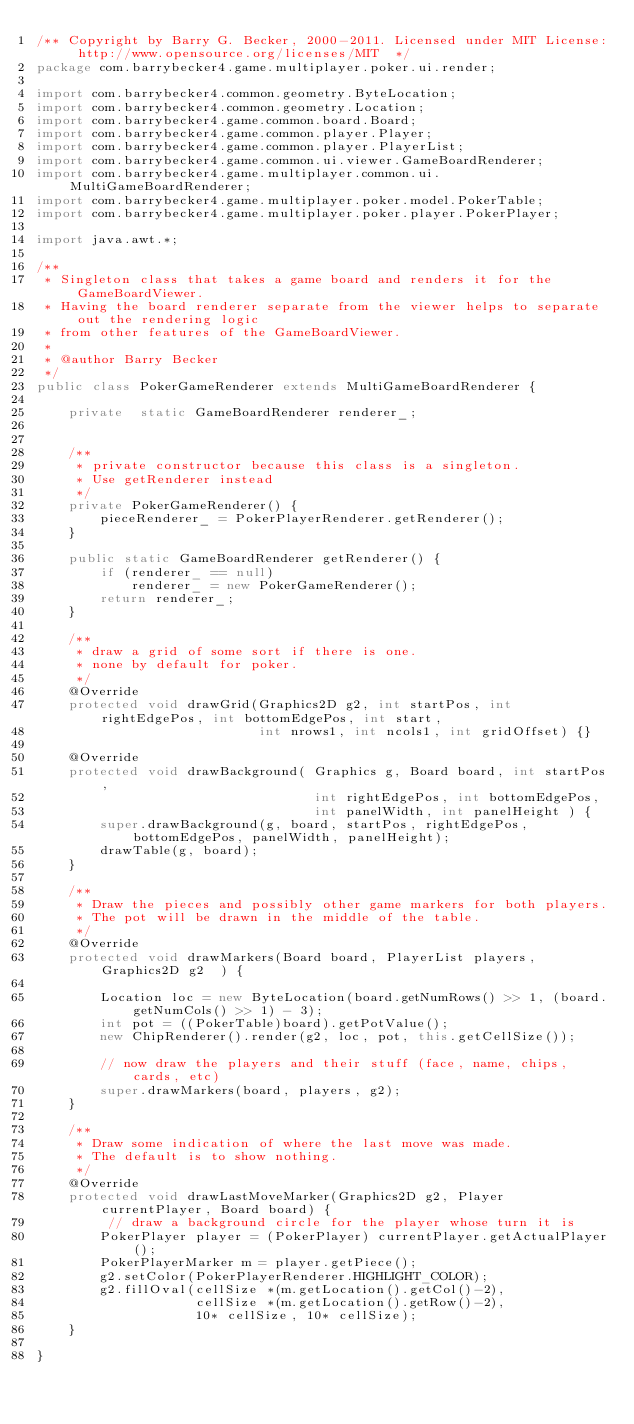Convert code to text. <code><loc_0><loc_0><loc_500><loc_500><_Java_>/** Copyright by Barry G. Becker, 2000-2011. Licensed under MIT License: http://www.opensource.org/licenses/MIT  */
package com.barrybecker4.game.multiplayer.poker.ui.render;

import com.barrybecker4.common.geometry.ByteLocation;
import com.barrybecker4.common.geometry.Location;
import com.barrybecker4.game.common.board.Board;
import com.barrybecker4.game.common.player.Player;
import com.barrybecker4.game.common.player.PlayerList;
import com.barrybecker4.game.common.ui.viewer.GameBoardRenderer;
import com.barrybecker4.game.multiplayer.common.ui.MultiGameBoardRenderer;
import com.barrybecker4.game.multiplayer.poker.model.PokerTable;
import com.barrybecker4.game.multiplayer.poker.player.PokerPlayer;

import java.awt.*;

/**
 * Singleton class that takes a game board and renders it for the GameBoardViewer.
 * Having the board renderer separate from the viewer helps to separate out the rendering logic
 * from other features of the GameBoardViewer.
 *
 * @author Barry Becker
 */
public class PokerGameRenderer extends MultiGameBoardRenderer {

    private  static GameBoardRenderer renderer_;


    /**
     * private constructor because this class is a singleton.
     * Use getRenderer instead
     */
    private PokerGameRenderer() {
        pieceRenderer_ = PokerPlayerRenderer.getRenderer();
    }

    public static GameBoardRenderer getRenderer() {
        if (renderer_ == null)
            renderer_ = new PokerGameRenderer();
        return renderer_;
    }

    /**
     * draw a grid of some sort if there is one.
     * none by default for poker.
     */
    @Override
    protected void drawGrid(Graphics2D g2, int startPos, int rightEdgePos, int bottomEdgePos, int start,
                            int nrows1, int ncols1, int gridOffset) {}

    @Override
    protected void drawBackground( Graphics g, Board board, int startPos,
                                   int rightEdgePos, int bottomEdgePos,
                                   int panelWidth, int panelHeight ) {
        super.drawBackground(g, board, startPos, rightEdgePos, bottomEdgePos, panelWidth, panelHeight);
        drawTable(g, board);
    }

    /**
     * Draw the pieces and possibly other game markers for both players.
     * The pot will be drawn in the middle of the table.
     */
    @Override
    protected void drawMarkers(Board board, PlayerList players, Graphics2D g2  ) {

        Location loc = new ByteLocation(board.getNumRows() >> 1, (board.getNumCols() >> 1) - 3);
        int pot = ((PokerTable)board).getPotValue();
        new ChipRenderer().render(g2, loc, pot, this.getCellSize());

        // now draw the players and their stuff (face, name, chips, cards, etc)
        super.drawMarkers(board, players, g2);
    }

    /**
     * Draw some indication of where the last move was made.
     * The default is to show nothing.
     */
    @Override
    protected void drawLastMoveMarker(Graphics2D g2, Player currentPlayer, Board board) {
         // draw a background circle for the player whose turn it is
        PokerPlayer player = (PokerPlayer) currentPlayer.getActualPlayer();
        PokerPlayerMarker m = player.getPiece();
        g2.setColor(PokerPlayerRenderer.HIGHLIGHT_COLOR);
        g2.fillOval(cellSize *(m.getLocation().getCol()-2),
                    cellSize *(m.getLocation().getRow()-2),
                    10* cellSize, 10* cellSize);
    }

}

</code> 